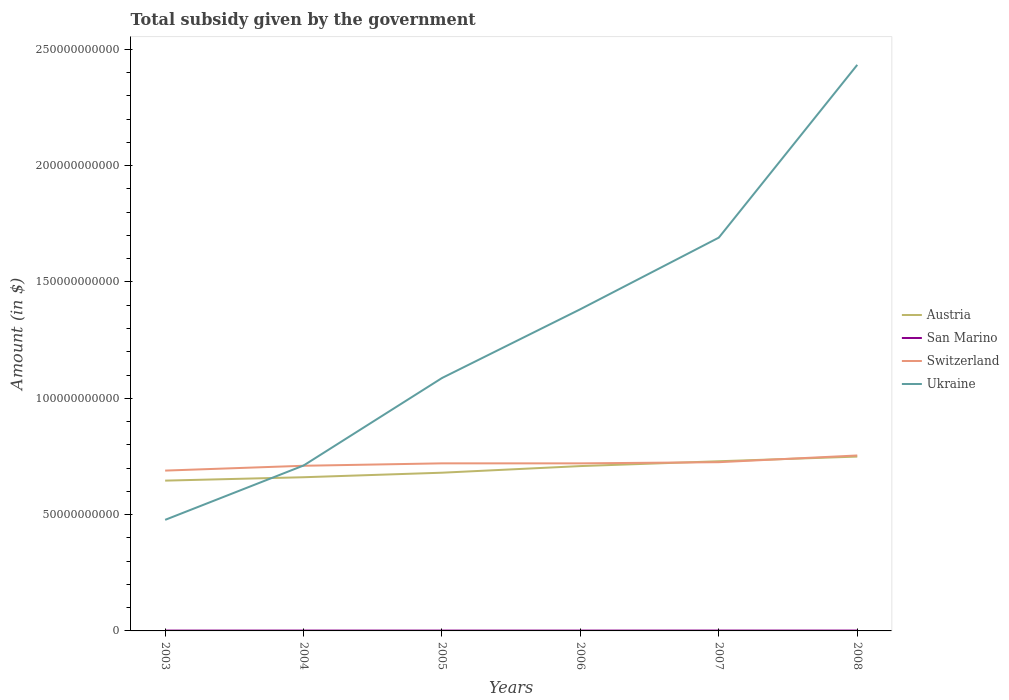Does the line corresponding to Austria intersect with the line corresponding to Ukraine?
Offer a very short reply. Yes. Is the number of lines equal to the number of legend labels?
Offer a very short reply. Yes. Across all years, what is the maximum total revenue collected by the government in San Marino?
Ensure brevity in your answer.  1.44e+08. In which year was the total revenue collected by the government in San Marino maximum?
Provide a short and direct response. 2006. What is the total total revenue collected by the government in Ukraine in the graph?
Offer a very short reply. -6.04e+1. What is the difference between the highest and the second highest total revenue collected by the government in San Marino?
Give a very brief answer. 1.87e+07. How many lines are there?
Make the answer very short. 4. How many years are there in the graph?
Your answer should be very brief. 6. Does the graph contain grids?
Provide a succinct answer. No. How many legend labels are there?
Make the answer very short. 4. How are the legend labels stacked?
Your answer should be very brief. Vertical. What is the title of the graph?
Provide a short and direct response. Total subsidy given by the government. Does "Belarus" appear as one of the legend labels in the graph?
Keep it short and to the point. No. What is the label or title of the Y-axis?
Your answer should be very brief. Amount (in $). What is the Amount (in $) of Austria in 2003?
Offer a terse response. 6.46e+1. What is the Amount (in $) of San Marino in 2003?
Offer a very short reply. 1.46e+08. What is the Amount (in $) in Switzerland in 2003?
Offer a very short reply. 6.89e+1. What is the Amount (in $) of Ukraine in 2003?
Offer a very short reply. 4.77e+1. What is the Amount (in $) of Austria in 2004?
Your response must be concise. 6.61e+1. What is the Amount (in $) in San Marino in 2004?
Offer a terse response. 1.53e+08. What is the Amount (in $) in Switzerland in 2004?
Provide a succinct answer. 7.10e+1. What is the Amount (in $) in Ukraine in 2004?
Give a very brief answer. 7.11e+1. What is the Amount (in $) of Austria in 2005?
Offer a terse response. 6.80e+1. What is the Amount (in $) of San Marino in 2005?
Ensure brevity in your answer.  1.49e+08. What is the Amount (in $) of Switzerland in 2005?
Provide a short and direct response. 7.20e+1. What is the Amount (in $) in Ukraine in 2005?
Offer a very short reply. 1.09e+11. What is the Amount (in $) in Austria in 2006?
Provide a short and direct response. 7.09e+1. What is the Amount (in $) of San Marino in 2006?
Keep it short and to the point. 1.44e+08. What is the Amount (in $) in Switzerland in 2006?
Provide a succinct answer. 7.20e+1. What is the Amount (in $) of Ukraine in 2006?
Give a very brief answer. 1.38e+11. What is the Amount (in $) of Austria in 2007?
Offer a very short reply. 7.29e+1. What is the Amount (in $) in San Marino in 2007?
Provide a short and direct response. 1.63e+08. What is the Amount (in $) in Switzerland in 2007?
Offer a very short reply. 7.25e+1. What is the Amount (in $) of Ukraine in 2007?
Provide a short and direct response. 1.69e+11. What is the Amount (in $) in Austria in 2008?
Offer a terse response. 7.49e+1. What is the Amount (in $) of San Marino in 2008?
Keep it short and to the point. 1.57e+08. What is the Amount (in $) in Switzerland in 2008?
Your response must be concise. 7.54e+1. What is the Amount (in $) in Ukraine in 2008?
Offer a terse response. 2.43e+11. Across all years, what is the maximum Amount (in $) in Austria?
Provide a short and direct response. 7.49e+1. Across all years, what is the maximum Amount (in $) in San Marino?
Keep it short and to the point. 1.63e+08. Across all years, what is the maximum Amount (in $) in Switzerland?
Provide a short and direct response. 7.54e+1. Across all years, what is the maximum Amount (in $) of Ukraine?
Provide a succinct answer. 2.43e+11. Across all years, what is the minimum Amount (in $) in Austria?
Your answer should be compact. 6.46e+1. Across all years, what is the minimum Amount (in $) in San Marino?
Your answer should be compact. 1.44e+08. Across all years, what is the minimum Amount (in $) in Switzerland?
Your answer should be compact. 6.89e+1. Across all years, what is the minimum Amount (in $) of Ukraine?
Make the answer very short. 4.77e+1. What is the total Amount (in $) of Austria in the graph?
Offer a very short reply. 4.17e+11. What is the total Amount (in $) in San Marino in the graph?
Provide a short and direct response. 9.12e+08. What is the total Amount (in $) in Switzerland in the graph?
Offer a very short reply. 4.32e+11. What is the total Amount (in $) of Ukraine in the graph?
Ensure brevity in your answer.  7.78e+11. What is the difference between the Amount (in $) in Austria in 2003 and that in 2004?
Ensure brevity in your answer.  -1.46e+09. What is the difference between the Amount (in $) of San Marino in 2003 and that in 2004?
Provide a succinct answer. -6.17e+06. What is the difference between the Amount (in $) of Switzerland in 2003 and that in 2004?
Provide a succinct answer. -2.08e+09. What is the difference between the Amount (in $) of Ukraine in 2003 and that in 2004?
Your answer should be compact. -2.34e+1. What is the difference between the Amount (in $) in Austria in 2003 and that in 2005?
Keep it short and to the point. -3.41e+09. What is the difference between the Amount (in $) of San Marino in 2003 and that in 2005?
Keep it short and to the point. -2.77e+06. What is the difference between the Amount (in $) of Switzerland in 2003 and that in 2005?
Give a very brief answer. -3.12e+09. What is the difference between the Amount (in $) in Ukraine in 2003 and that in 2005?
Make the answer very short. -6.10e+1. What is the difference between the Amount (in $) in Austria in 2003 and that in 2006?
Ensure brevity in your answer.  -6.25e+09. What is the difference between the Amount (in $) of San Marino in 2003 and that in 2006?
Offer a terse response. 2.18e+06. What is the difference between the Amount (in $) of Switzerland in 2003 and that in 2006?
Give a very brief answer. -3.10e+09. What is the difference between the Amount (in $) of Ukraine in 2003 and that in 2006?
Your answer should be compact. -9.05e+1. What is the difference between the Amount (in $) in Austria in 2003 and that in 2007?
Offer a very short reply. -8.33e+09. What is the difference between the Amount (in $) in San Marino in 2003 and that in 2007?
Give a very brief answer. -1.65e+07. What is the difference between the Amount (in $) of Switzerland in 2003 and that in 2007?
Your answer should be compact. -3.61e+09. What is the difference between the Amount (in $) of Ukraine in 2003 and that in 2007?
Your response must be concise. -1.21e+11. What is the difference between the Amount (in $) in Austria in 2003 and that in 2008?
Ensure brevity in your answer.  -1.03e+1. What is the difference between the Amount (in $) in San Marino in 2003 and that in 2008?
Keep it short and to the point. -1.01e+07. What is the difference between the Amount (in $) in Switzerland in 2003 and that in 2008?
Your response must be concise. -6.50e+09. What is the difference between the Amount (in $) in Ukraine in 2003 and that in 2008?
Provide a short and direct response. -1.96e+11. What is the difference between the Amount (in $) of Austria in 2004 and that in 2005?
Offer a terse response. -1.95e+09. What is the difference between the Amount (in $) in San Marino in 2004 and that in 2005?
Make the answer very short. 3.40e+06. What is the difference between the Amount (in $) in Switzerland in 2004 and that in 2005?
Offer a very short reply. -1.04e+09. What is the difference between the Amount (in $) of Ukraine in 2004 and that in 2005?
Offer a very short reply. -3.76e+1. What is the difference between the Amount (in $) in Austria in 2004 and that in 2006?
Your answer should be compact. -4.79e+09. What is the difference between the Amount (in $) of San Marino in 2004 and that in 2006?
Your answer should be very brief. 8.35e+06. What is the difference between the Amount (in $) of Switzerland in 2004 and that in 2006?
Offer a very short reply. -1.03e+09. What is the difference between the Amount (in $) in Ukraine in 2004 and that in 2006?
Offer a terse response. -6.72e+1. What is the difference between the Amount (in $) of Austria in 2004 and that in 2007?
Your response must be concise. -6.87e+09. What is the difference between the Amount (in $) of San Marino in 2004 and that in 2007?
Your answer should be compact. -1.04e+07. What is the difference between the Amount (in $) in Switzerland in 2004 and that in 2007?
Your answer should be very brief. -1.53e+09. What is the difference between the Amount (in $) of Ukraine in 2004 and that in 2007?
Provide a succinct answer. -9.80e+1. What is the difference between the Amount (in $) of Austria in 2004 and that in 2008?
Your response must be concise. -8.87e+09. What is the difference between the Amount (in $) of San Marino in 2004 and that in 2008?
Your response must be concise. -3.96e+06. What is the difference between the Amount (in $) of Switzerland in 2004 and that in 2008?
Offer a terse response. -4.42e+09. What is the difference between the Amount (in $) in Ukraine in 2004 and that in 2008?
Provide a short and direct response. -1.72e+11. What is the difference between the Amount (in $) in Austria in 2005 and that in 2006?
Offer a terse response. -2.85e+09. What is the difference between the Amount (in $) in San Marino in 2005 and that in 2006?
Offer a very short reply. 4.95e+06. What is the difference between the Amount (in $) in Switzerland in 2005 and that in 2006?
Your answer should be compact. 1.11e+07. What is the difference between the Amount (in $) in Ukraine in 2005 and that in 2006?
Your response must be concise. -2.96e+1. What is the difference between the Amount (in $) of Austria in 2005 and that in 2007?
Offer a very short reply. -4.92e+09. What is the difference between the Amount (in $) of San Marino in 2005 and that in 2007?
Offer a terse response. -1.38e+07. What is the difference between the Amount (in $) in Switzerland in 2005 and that in 2007?
Keep it short and to the point. -4.96e+08. What is the difference between the Amount (in $) of Ukraine in 2005 and that in 2007?
Provide a short and direct response. -6.04e+1. What is the difference between the Amount (in $) in Austria in 2005 and that in 2008?
Your answer should be very brief. -6.93e+09. What is the difference between the Amount (in $) in San Marino in 2005 and that in 2008?
Give a very brief answer. -7.36e+06. What is the difference between the Amount (in $) in Switzerland in 2005 and that in 2008?
Provide a succinct answer. -3.39e+09. What is the difference between the Amount (in $) in Ukraine in 2005 and that in 2008?
Your response must be concise. -1.35e+11. What is the difference between the Amount (in $) of Austria in 2006 and that in 2007?
Ensure brevity in your answer.  -2.08e+09. What is the difference between the Amount (in $) in San Marino in 2006 and that in 2007?
Your answer should be very brief. -1.87e+07. What is the difference between the Amount (in $) in Switzerland in 2006 and that in 2007?
Your answer should be compact. -5.07e+08. What is the difference between the Amount (in $) of Ukraine in 2006 and that in 2007?
Give a very brief answer. -3.08e+1. What is the difference between the Amount (in $) of Austria in 2006 and that in 2008?
Offer a terse response. -4.08e+09. What is the difference between the Amount (in $) of San Marino in 2006 and that in 2008?
Keep it short and to the point. -1.23e+07. What is the difference between the Amount (in $) of Switzerland in 2006 and that in 2008?
Make the answer very short. -3.40e+09. What is the difference between the Amount (in $) in Ukraine in 2006 and that in 2008?
Give a very brief answer. -1.05e+11. What is the difference between the Amount (in $) in Austria in 2007 and that in 2008?
Provide a succinct answer. -2.01e+09. What is the difference between the Amount (in $) in San Marino in 2007 and that in 2008?
Offer a very short reply. 6.40e+06. What is the difference between the Amount (in $) in Switzerland in 2007 and that in 2008?
Provide a succinct answer. -2.89e+09. What is the difference between the Amount (in $) in Ukraine in 2007 and that in 2008?
Provide a short and direct response. -7.42e+1. What is the difference between the Amount (in $) of Austria in 2003 and the Amount (in $) of San Marino in 2004?
Your answer should be compact. 6.45e+1. What is the difference between the Amount (in $) in Austria in 2003 and the Amount (in $) in Switzerland in 2004?
Give a very brief answer. -6.39e+09. What is the difference between the Amount (in $) of Austria in 2003 and the Amount (in $) of Ukraine in 2004?
Offer a terse response. -6.49e+09. What is the difference between the Amount (in $) of San Marino in 2003 and the Amount (in $) of Switzerland in 2004?
Ensure brevity in your answer.  -7.08e+1. What is the difference between the Amount (in $) of San Marino in 2003 and the Amount (in $) of Ukraine in 2004?
Keep it short and to the point. -7.10e+1. What is the difference between the Amount (in $) of Switzerland in 2003 and the Amount (in $) of Ukraine in 2004?
Offer a terse response. -2.18e+09. What is the difference between the Amount (in $) in Austria in 2003 and the Amount (in $) in San Marino in 2005?
Your answer should be compact. 6.45e+1. What is the difference between the Amount (in $) of Austria in 2003 and the Amount (in $) of Switzerland in 2005?
Your answer should be very brief. -7.43e+09. What is the difference between the Amount (in $) of Austria in 2003 and the Amount (in $) of Ukraine in 2005?
Your response must be concise. -4.41e+1. What is the difference between the Amount (in $) of San Marino in 2003 and the Amount (in $) of Switzerland in 2005?
Offer a very short reply. -7.19e+1. What is the difference between the Amount (in $) of San Marino in 2003 and the Amount (in $) of Ukraine in 2005?
Provide a succinct answer. -1.09e+11. What is the difference between the Amount (in $) of Switzerland in 2003 and the Amount (in $) of Ukraine in 2005?
Your answer should be compact. -3.98e+1. What is the difference between the Amount (in $) of Austria in 2003 and the Amount (in $) of San Marino in 2006?
Keep it short and to the point. 6.45e+1. What is the difference between the Amount (in $) of Austria in 2003 and the Amount (in $) of Switzerland in 2006?
Provide a succinct answer. -7.42e+09. What is the difference between the Amount (in $) of Austria in 2003 and the Amount (in $) of Ukraine in 2006?
Your response must be concise. -7.37e+1. What is the difference between the Amount (in $) of San Marino in 2003 and the Amount (in $) of Switzerland in 2006?
Your answer should be compact. -7.19e+1. What is the difference between the Amount (in $) of San Marino in 2003 and the Amount (in $) of Ukraine in 2006?
Your response must be concise. -1.38e+11. What is the difference between the Amount (in $) in Switzerland in 2003 and the Amount (in $) in Ukraine in 2006?
Offer a very short reply. -6.94e+1. What is the difference between the Amount (in $) of Austria in 2003 and the Amount (in $) of San Marino in 2007?
Make the answer very short. 6.44e+1. What is the difference between the Amount (in $) of Austria in 2003 and the Amount (in $) of Switzerland in 2007?
Your answer should be very brief. -7.92e+09. What is the difference between the Amount (in $) of Austria in 2003 and the Amount (in $) of Ukraine in 2007?
Offer a terse response. -1.04e+11. What is the difference between the Amount (in $) in San Marino in 2003 and the Amount (in $) in Switzerland in 2007?
Provide a succinct answer. -7.24e+1. What is the difference between the Amount (in $) in San Marino in 2003 and the Amount (in $) in Ukraine in 2007?
Offer a very short reply. -1.69e+11. What is the difference between the Amount (in $) in Switzerland in 2003 and the Amount (in $) in Ukraine in 2007?
Your response must be concise. -1.00e+11. What is the difference between the Amount (in $) in Austria in 2003 and the Amount (in $) in San Marino in 2008?
Offer a terse response. 6.44e+1. What is the difference between the Amount (in $) in Austria in 2003 and the Amount (in $) in Switzerland in 2008?
Provide a succinct answer. -1.08e+1. What is the difference between the Amount (in $) of Austria in 2003 and the Amount (in $) of Ukraine in 2008?
Keep it short and to the point. -1.79e+11. What is the difference between the Amount (in $) of San Marino in 2003 and the Amount (in $) of Switzerland in 2008?
Ensure brevity in your answer.  -7.53e+1. What is the difference between the Amount (in $) of San Marino in 2003 and the Amount (in $) of Ukraine in 2008?
Provide a succinct answer. -2.43e+11. What is the difference between the Amount (in $) in Switzerland in 2003 and the Amount (in $) in Ukraine in 2008?
Offer a terse response. -1.74e+11. What is the difference between the Amount (in $) in Austria in 2004 and the Amount (in $) in San Marino in 2005?
Offer a terse response. 6.59e+1. What is the difference between the Amount (in $) in Austria in 2004 and the Amount (in $) in Switzerland in 2005?
Your answer should be compact. -5.97e+09. What is the difference between the Amount (in $) of Austria in 2004 and the Amount (in $) of Ukraine in 2005?
Your response must be concise. -4.26e+1. What is the difference between the Amount (in $) in San Marino in 2004 and the Amount (in $) in Switzerland in 2005?
Make the answer very short. -7.19e+1. What is the difference between the Amount (in $) of San Marino in 2004 and the Amount (in $) of Ukraine in 2005?
Make the answer very short. -1.09e+11. What is the difference between the Amount (in $) in Switzerland in 2004 and the Amount (in $) in Ukraine in 2005?
Provide a short and direct response. -3.77e+1. What is the difference between the Amount (in $) in Austria in 2004 and the Amount (in $) in San Marino in 2006?
Offer a very short reply. 6.59e+1. What is the difference between the Amount (in $) in Austria in 2004 and the Amount (in $) in Switzerland in 2006?
Your response must be concise. -5.96e+09. What is the difference between the Amount (in $) of Austria in 2004 and the Amount (in $) of Ukraine in 2006?
Your response must be concise. -7.22e+1. What is the difference between the Amount (in $) of San Marino in 2004 and the Amount (in $) of Switzerland in 2006?
Keep it short and to the point. -7.19e+1. What is the difference between the Amount (in $) of San Marino in 2004 and the Amount (in $) of Ukraine in 2006?
Your answer should be compact. -1.38e+11. What is the difference between the Amount (in $) of Switzerland in 2004 and the Amount (in $) of Ukraine in 2006?
Your response must be concise. -6.73e+1. What is the difference between the Amount (in $) in Austria in 2004 and the Amount (in $) in San Marino in 2007?
Keep it short and to the point. 6.59e+1. What is the difference between the Amount (in $) in Austria in 2004 and the Amount (in $) in Switzerland in 2007?
Make the answer very short. -6.47e+09. What is the difference between the Amount (in $) in Austria in 2004 and the Amount (in $) in Ukraine in 2007?
Make the answer very short. -1.03e+11. What is the difference between the Amount (in $) in San Marino in 2004 and the Amount (in $) in Switzerland in 2007?
Your response must be concise. -7.24e+1. What is the difference between the Amount (in $) in San Marino in 2004 and the Amount (in $) in Ukraine in 2007?
Your answer should be very brief. -1.69e+11. What is the difference between the Amount (in $) in Switzerland in 2004 and the Amount (in $) in Ukraine in 2007?
Your response must be concise. -9.81e+1. What is the difference between the Amount (in $) of Austria in 2004 and the Amount (in $) of San Marino in 2008?
Provide a short and direct response. 6.59e+1. What is the difference between the Amount (in $) of Austria in 2004 and the Amount (in $) of Switzerland in 2008?
Your response must be concise. -9.36e+09. What is the difference between the Amount (in $) in Austria in 2004 and the Amount (in $) in Ukraine in 2008?
Your response must be concise. -1.77e+11. What is the difference between the Amount (in $) in San Marino in 2004 and the Amount (in $) in Switzerland in 2008?
Provide a succinct answer. -7.53e+1. What is the difference between the Amount (in $) in San Marino in 2004 and the Amount (in $) in Ukraine in 2008?
Keep it short and to the point. -2.43e+11. What is the difference between the Amount (in $) of Switzerland in 2004 and the Amount (in $) of Ukraine in 2008?
Ensure brevity in your answer.  -1.72e+11. What is the difference between the Amount (in $) of Austria in 2005 and the Amount (in $) of San Marino in 2006?
Your answer should be compact. 6.79e+1. What is the difference between the Amount (in $) of Austria in 2005 and the Amount (in $) of Switzerland in 2006?
Your response must be concise. -4.01e+09. What is the difference between the Amount (in $) in Austria in 2005 and the Amount (in $) in Ukraine in 2006?
Make the answer very short. -7.03e+1. What is the difference between the Amount (in $) in San Marino in 2005 and the Amount (in $) in Switzerland in 2006?
Make the answer very short. -7.19e+1. What is the difference between the Amount (in $) in San Marino in 2005 and the Amount (in $) in Ukraine in 2006?
Your answer should be very brief. -1.38e+11. What is the difference between the Amount (in $) of Switzerland in 2005 and the Amount (in $) of Ukraine in 2006?
Your response must be concise. -6.63e+1. What is the difference between the Amount (in $) of Austria in 2005 and the Amount (in $) of San Marino in 2007?
Your answer should be compact. 6.78e+1. What is the difference between the Amount (in $) of Austria in 2005 and the Amount (in $) of Switzerland in 2007?
Your response must be concise. -4.52e+09. What is the difference between the Amount (in $) in Austria in 2005 and the Amount (in $) in Ukraine in 2007?
Provide a succinct answer. -1.01e+11. What is the difference between the Amount (in $) in San Marino in 2005 and the Amount (in $) in Switzerland in 2007?
Offer a very short reply. -7.24e+1. What is the difference between the Amount (in $) of San Marino in 2005 and the Amount (in $) of Ukraine in 2007?
Give a very brief answer. -1.69e+11. What is the difference between the Amount (in $) in Switzerland in 2005 and the Amount (in $) in Ukraine in 2007?
Give a very brief answer. -9.70e+1. What is the difference between the Amount (in $) of Austria in 2005 and the Amount (in $) of San Marino in 2008?
Provide a short and direct response. 6.79e+1. What is the difference between the Amount (in $) of Austria in 2005 and the Amount (in $) of Switzerland in 2008?
Give a very brief answer. -7.41e+09. What is the difference between the Amount (in $) in Austria in 2005 and the Amount (in $) in Ukraine in 2008?
Provide a short and direct response. -1.75e+11. What is the difference between the Amount (in $) in San Marino in 2005 and the Amount (in $) in Switzerland in 2008?
Make the answer very short. -7.53e+1. What is the difference between the Amount (in $) of San Marino in 2005 and the Amount (in $) of Ukraine in 2008?
Offer a very short reply. -2.43e+11. What is the difference between the Amount (in $) in Switzerland in 2005 and the Amount (in $) in Ukraine in 2008?
Your response must be concise. -1.71e+11. What is the difference between the Amount (in $) in Austria in 2006 and the Amount (in $) in San Marino in 2007?
Your answer should be compact. 7.07e+1. What is the difference between the Amount (in $) in Austria in 2006 and the Amount (in $) in Switzerland in 2007?
Your response must be concise. -1.67e+09. What is the difference between the Amount (in $) in Austria in 2006 and the Amount (in $) in Ukraine in 2007?
Offer a terse response. -9.82e+1. What is the difference between the Amount (in $) of San Marino in 2006 and the Amount (in $) of Switzerland in 2007?
Your response must be concise. -7.24e+1. What is the difference between the Amount (in $) in San Marino in 2006 and the Amount (in $) in Ukraine in 2007?
Offer a terse response. -1.69e+11. What is the difference between the Amount (in $) of Switzerland in 2006 and the Amount (in $) of Ukraine in 2007?
Your answer should be very brief. -9.70e+1. What is the difference between the Amount (in $) of Austria in 2006 and the Amount (in $) of San Marino in 2008?
Offer a very short reply. 7.07e+1. What is the difference between the Amount (in $) of Austria in 2006 and the Amount (in $) of Switzerland in 2008?
Ensure brevity in your answer.  -4.56e+09. What is the difference between the Amount (in $) in Austria in 2006 and the Amount (in $) in Ukraine in 2008?
Your answer should be compact. -1.72e+11. What is the difference between the Amount (in $) of San Marino in 2006 and the Amount (in $) of Switzerland in 2008?
Your answer should be very brief. -7.53e+1. What is the difference between the Amount (in $) of San Marino in 2006 and the Amount (in $) of Ukraine in 2008?
Your answer should be compact. -2.43e+11. What is the difference between the Amount (in $) of Switzerland in 2006 and the Amount (in $) of Ukraine in 2008?
Make the answer very short. -1.71e+11. What is the difference between the Amount (in $) in Austria in 2007 and the Amount (in $) in San Marino in 2008?
Your response must be concise. 7.28e+1. What is the difference between the Amount (in $) of Austria in 2007 and the Amount (in $) of Switzerland in 2008?
Make the answer very short. -2.49e+09. What is the difference between the Amount (in $) in Austria in 2007 and the Amount (in $) in Ukraine in 2008?
Offer a terse response. -1.70e+11. What is the difference between the Amount (in $) in San Marino in 2007 and the Amount (in $) in Switzerland in 2008?
Your answer should be compact. -7.53e+1. What is the difference between the Amount (in $) of San Marino in 2007 and the Amount (in $) of Ukraine in 2008?
Provide a short and direct response. -2.43e+11. What is the difference between the Amount (in $) of Switzerland in 2007 and the Amount (in $) of Ukraine in 2008?
Your answer should be very brief. -1.71e+11. What is the average Amount (in $) of Austria per year?
Give a very brief answer. 6.96e+1. What is the average Amount (in $) of San Marino per year?
Give a very brief answer. 1.52e+08. What is the average Amount (in $) in Switzerland per year?
Offer a very short reply. 7.20e+1. What is the average Amount (in $) in Ukraine per year?
Keep it short and to the point. 1.30e+11. In the year 2003, what is the difference between the Amount (in $) of Austria and Amount (in $) of San Marino?
Ensure brevity in your answer.  6.45e+1. In the year 2003, what is the difference between the Amount (in $) of Austria and Amount (in $) of Switzerland?
Offer a very short reply. -4.31e+09. In the year 2003, what is the difference between the Amount (in $) of Austria and Amount (in $) of Ukraine?
Your answer should be compact. 1.69e+1. In the year 2003, what is the difference between the Amount (in $) in San Marino and Amount (in $) in Switzerland?
Make the answer very short. -6.88e+1. In the year 2003, what is the difference between the Amount (in $) of San Marino and Amount (in $) of Ukraine?
Your answer should be very brief. -4.76e+1. In the year 2003, what is the difference between the Amount (in $) of Switzerland and Amount (in $) of Ukraine?
Provide a short and direct response. 2.12e+1. In the year 2004, what is the difference between the Amount (in $) of Austria and Amount (in $) of San Marino?
Offer a very short reply. 6.59e+1. In the year 2004, what is the difference between the Amount (in $) of Austria and Amount (in $) of Switzerland?
Your response must be concise. -4.93e+09. In the year 2004, what is the difference between the Amount (in $) in Austria and Amount (in $) in Ukraine?
Provide a short and direct response. -5.04e+09. In the year 2004, what is the difference between the Amount (in $) of San Marino and Amount (in $) of Switzerland?
Your answer should be compact. -7.08e+1. In the year 2004, what is the difference between the Amount (in $) of San Marino and Amount (in $) of Ukraine?
Your answer should be compact. -7.09e+1. In the year 2004, what is the difference between the Amount (in $) of Switzerland and Amount (in $) of Ukraine?
Your response must be concise. -1.06e+08. In the year 2005, what is the difference between the Amount (in $) in Austria and Amount (in $) in San Marino?
Your response must be concise. 6.79e+1. In the year 2005, what is the difference between the Amount (in $) of Austria and Amount (in $) of Switzerland?
Offer a very short reply. -4.02e+09. In the year 2005, what is the difference between the Amount (in $) in Austria and Amount (in $) in Ukraine?
Make the answer very short. -4.07e+1. In the year 2005, what is the difference between the Amount (in $) of San Marino and Amount (in $) of Switzerland?
Your answer should be compact. -7.19e+1. In the year 2005, what is the difference between the Amount (in $) of San Marino and Amount (in $) of Ukraine?
Provide a succinct answer. -1.09e+11. In the year 2005, what is the difference between the Amount (in $) of Switzerland and Amount (in $) of Ukraine?
Offer a terse response. -3.67e+1. In the year 2006, what is the difference between the Amount (in $) in Austria and Amount (in $) in San Marino?
Offer a very short reply. 7.07e+1. In the year 2006, what is the difference between the Amount (in $) in Austria and Amount (in $) in Switzerland?
Keep it short and to the point. -1.17e+09. In the year 2006, what is the difference between the Amount (in $) in Austria and Amount (in $) in Ukraine?
Your answer should be very brief. -6.74e+1. In the year 2006, what is the difference between the Amount (in $) in San Marino and Amount (in $) in Switzerland?
Offer a terse response. -7.19e+1. In the year 2006, what is the difference between the Amount (in $) of San Marino and Amount (in $) of Ukraine?
Ensure brevity in your answer.  -1.38e+11. In the year 2006, what is the difference between the Amount (in $) of Switzerland and Amount (in $) of Ukraine?
Make the answer very short. -6.63e+1. In the year 2007, what is the difference between the Amount (in $) in Austria and Amount (in $) in San Marino?
Provide a succinct answer. 7.28e+1. In the year 2007, what is the difference between the Amount (in $) in Austria and Amount (in $) in Switzerland?
Offer a very short reply. 4.03e+08. In the year 2007, what is the difference between the Amount (in $) in Austria and Amount (in $) in Ukraine?
Your answer should be compact. -9.61e+1. In the year 2007, what is the difference between the Amount (in $) of San Marino and Amount (in $) of Switzerland?
Offer a terse response. -7.24e+1. In the year 2007, what is the difference between the Amount (in $) in San Marino and Amount (in $) in Ukraine?
Provide a short and direct response. -1.69e+11. In the year 2007, what is the difference between the Amount (in $) of Switzerland and Amount (in $) of Ukraine?
Give a very brief answer. -9.65e+1. In the year 2008, what is the difference between the Amount (in $) in Austria and Amount (in $) in San Marino?
Keep it short and to the point. 7.48e+1. In the year 2008, what is the difference between the Amount (in $) of Austria and Amount (in $) of Switzerland?
Offer a very short reply. -4.81e+08. In the year 2008, what is the difference between the Amount (in $) of Austria and Amount (in $) of Ukraine?
Provide a succinct answer. -1.68e+11. In the year 2008, what is the difference between the Amount (in $) in San Marino and Amount (in $) in Switzerland?
Keep it short and to the point. -7.53e+1. In the year 2008, what is the difference between the Amount (in $) in San Marino and Amount (in $) in Ukraine?
Provide a succinct answer. -2.43e+11. In the year 2008, what is the difference between the Amount (in $) of Switzerland and Amount (in $) of Ukraine?
Provide a succinct answer. -1.68e+11. What is the ratio of the Amount (in $) of Austria in 2003 to that in 2004?
Offer a terse response. 0.98. What is the ratio of the Amount (in $) of San Marino in 2003 to that in 2004?
Ensure brevity in your answer.  0.96. What is the ratio of the Amount (in $) in Switzerland in 2003 to that in 2004?
Ensure brevity in your answer.  0.97. What is the ratio of the Amount (in $) in Ukraine in 2003 to that in 2004?
Keep it short and to the point. 0.67. What is the ratio of the Amount (in $) of Austria in 2003 to that in 2005?
Provide a short and direct response. 0.95. What is the ratio of the Amount (in $) in San Marino in 2003 to that in 2005?
Keep it short and to the point. 0.98. What is the ratio of the Amount (in $) in Switzerland in 2003 to that in 2005?
Ensure brevity in your answer.  0.96. What is the ratio of the Amount (in $) of Ukraine in 2003 to that in 2005?
Your response must be concise. 0.44. What is the ratio of the Amount (in $) in Austria in 2003 to that in 2006?
Your response must be concise. 0.91. What is the ratio of the Amount (in $) in San Marino in 2003 to that in 2006?
Your response must be concise. 1.02. What is the ratio of the Amount (in $) of Switzerland in 2003 to that in 2006?
Ensure brevity in your answer.  0.96. What is the ratio of the Amount (in $) of Ukraine in 2003 to that in 2006?
Your answer should be compact. 0.35. What is the ratio of the Amount (in $) in Austria in 2003 to that in 2007?
Provide a succinct answer. 0.89. What is the ratio of the Amount (in $) of San Marino in 2003 to that in 2007?
Your answer should be compact. 0.9. What is the ratio of the Amount (in $) of Switzerland in 2003 to that in 2007?
Make the answer very short. 0.95. What is the ratio of the Amount (in $) of Ukraine in 2003 to that in 2007?
Your answer should be very brief. 0.28. What is the ratio of the Amount (in $) in Austria in 2003 to that in 2008?
Offer a terse response. 0.86. What is the ratio of the Amount (in $) of San Marino in 2003 to that in 2008?
Ensure brevity in your answer.  0.94. What is the ratio of the Amount (in $) in Switzerland in 2003 to that in 2008?
Your response must be concise. 0.91. What is the ratio of the Amount (in $) of Ukraine in 2003 to that in 2008?
Your answer should be very brief. 0.2. What is the ratio of the Amount (in $) of Austria in 2004 to that in 2005?
Keep it short and to the point. 0.97. What is the ratio of the Amount (in $) in San Marino in 2004 to that in 2005?
Ensure brevity in your answer.  1.02. What is the ratio of the Amount (in $) in Switzerland in 2004 to that in 2005?
Offer a very short reply. 0.99. What is the ratio of the Amount (in $) in Ukraine in 2004 to that in 2005?
Give a very brief answer. 0.65. What is the ratio of the Amount (in $) of Austria in 2004 to that in 2006?
Keep it short and to the point. 0.93. What is the ratio of the Amount (in $) of San Marino in 2004 to that in 2006?
Give a very brief answer. 1.06. What is the ratio of the Amount (in $) in Switzerland in 2004 to that in 2006?
Offer a terse response. 0.99. What is the ratio of the Amount (in $) in Ukraine in 2004 to that in 2006?
Your answer should be very brief. 0.51. What is the ratio of the Amount (in $) of Austria in 2004 to that in 2007?
Offer a very short reply. 0.91. What is the ratio of the Amount (in $) in San Marino in 2004 to that in 2007?
Offer a very short reply. 0.94. What is the ratio of the Amount (in $) of Switzerland in 2004 to that in 2007?
Ensure brevity in your answer.  0.98. What is the ratio of the Amount (in $) of Ukraine in 2004 to that in 2007?
Keep it short and to the point. 0.42. What is the ratio of the Amount (in $) in Austria in 2004 to that in 2008?
Give a very brief answer. 0.88. What is the ratio of the Amount (in $) in San Marino in 2004 to that in 2008?
Offer a terse response. 0.97. What is the ratio of the Amount (in $) of Switzerland in 2004 to that in 2008?
Provide a succinct answer. 0.94. What is the ratio of the Amount (in $) in Ukraine in 2004 to that in 2008?
Make the answer very short. 0.29. What is the ratio of the Amount (in $) of Austria in 2005 to that in 2006?
Give a very brief answer. 0.96. What is the ratio of the Amount (in $) in San Marino in 2005 to that in 2006?
Keep it short and to the point. 1.03. What is the ratio of the Amount (in $) of Ukraine in 2005 to that in 2006?
Make the answer very short. 0.79. What is the ratio of the Amount (in $) of Austria in 2005 to that in 2007?
Make the answer very short. 0.93. What is the ratio of the Amount (in $) of San Marino in 2005 to that in 2007?
Offer a terse response. 0.92. What is the ratio of the Amount (in $) of Switzerland in 2005 to that in 2007?
Make the answer very short. 0.99. What is the ratio of the Amount (in $) of Ukraine in 2005 to that in 2007?
Your answer should be very brief. 0.64. What is the ratio of the Amount (in $) of Austria in 2005 to that in 2008?
Your answer should be compact. 0.91. What is the ratio of the Amount (in $) of San Marino in 2005 to that in 2008?
Your answer should be very brief. 0.95. What is the ratio of the Amount (in $) of Switzerland in 2005 to that in 2008?
Your response must be concise. 0.96. What is the ratio of the Amount (in $) in Ukraine in 2005 to that in 2008?
Give a very brief answer. 0.45. What is the ratio of the Amount (in $) in Austria in 2006 to that in 2007?
Offer a terse response. 0.97. What is the ratio of the Amount (in $) of San Marino in 2006 to that in 2007?
Offer a very short reply. 0.89. What is the ratio of the Amount (in $) of Switzerland in 2006 to that in 2007?
Offer a terse response. 0.99. What is the ratio of the Amount (in $) in Ukraine in 2006 to that in 2007?
Provide a short and direct response. 0.82. What is the ratio of the Amount (in $) in Austria in 2006 to that in 2008?
Your response must be concise. 0.95. What is the ratio of the Amount (in $) of San Marino in 2006 to that in 2008?
Provide a succinct answer. 0.92. What is the ratio of the Amount (in $) in Switzerland in 2006 to that in 2008?
Give a very brief answer. 0.95. What is the ratio of the Amount (in $) of Ukraine in 2006 to that in 2008?
Keep it short and to the point. 0.57. What is the ratio of the Amount (in $) of Austria in 2007 to that in 2008?
Make the answer very short. 0.97. What is the ratio of the Amount (in $) of San Marino in 2007 to that in 2008?
Make the answer very short. 1.04. What is the ratio of the Amount (in $) of Switzerland in 2007 to that in 2008?
Provide a succinct answer. 0.96. What is the ratio of the Amount (in $) of Ukraine in 2007 to that in 2008?
Make the answer very short. 0.69. What is the difference between the highest and the second highest Amount (in $) in Austria?
Ensure brevity in your answer.  2.01e+09. What is the difference between the highest and the second highest Amount (in $) of San Marino?
Offer a terse response. 6.40e+06. What is the difference between the highest and the second highest Amount (in $) in Switzerland?
Your response must be concise. 2.89e+09. What is the difference between the highest and the second highest Amount (in $) in Ukraine?
Ensure brevity in your answer.  7.42e+1. What is the difference between the highest and the lowest Amount (in $) in Austria?
Offer a very short reply. 1.03e+1. What is the difference between the highest and the lowest Amount (in $) of San Marino?
Provide a short and direct response. 1.87e+07. What is the difference between the highest and the lowest Amount (in $) of Switzerland?
Offer a very short reply. 6.50e+09. What is the difference between the highest and the lowest Amount (in $) in Ukraine?
Offer a terse response. 1.96e+11. 